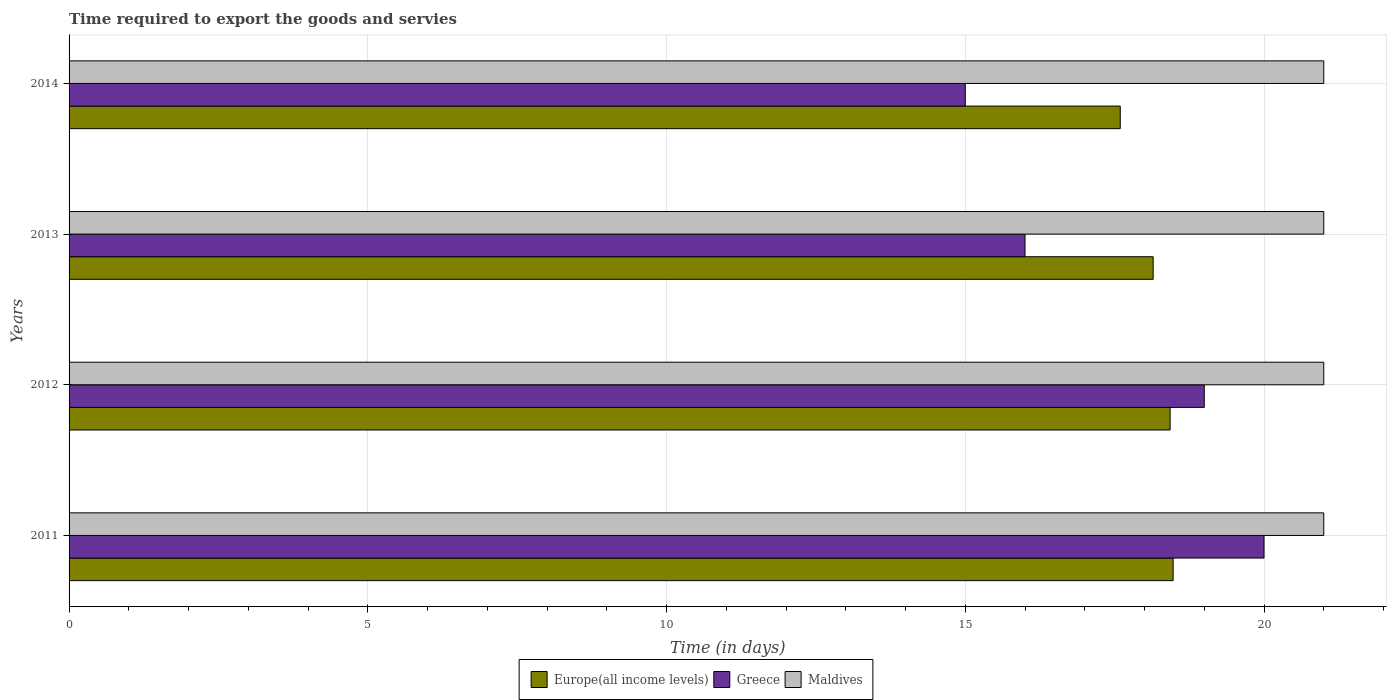How many groups of bars are there?
Give a very brief answer. 4. Are the number of bars per tick equal to the number of legend labels?
Ensure brevity in your answer.  Yes. How many bars are there on the 4th tick from the top?
Ensure brevity in your answer.  3. How many bars are there on the 1st tick from the bottom?
Offer a very short reply. 3. What is the number of days required to export the goods and services in Maldives in 2014?
Keep it short and to the point. 21. Across all years, what is the maximum number of days required to export the goods and services in Greece?
Provide a succinct answer. 20. Across all years, what is the minimum number of days required to export the goods and services in Greece?
Offer a very short reply. 15. In which year was the number of days required to export the goods and services in Europe(all income levels) maximum?
Your answer should be very brief. 2011. What is the total number of days required to export the goods and services in Europe(all income levels) in the graph?
Provide a succinct answer. 72.65. What is the difference between the number of days required to export the goods and services in Greece in 2011 and that in 2012?
Give a very brief answer. 1. What is the difference between the number of days required to export the goods and services in Greece in 2014 and the number of days required to export the goods and services in Europe(all income levels) in 2012?
Offer a very short reply. -3.43. What is the average number of days required to export the goods and services in Maldives per year?
Your answer should be very brief. 21. In the year 2012, what is the difference between the number of days required to export the goods and services in Greece and number of days required to export the goods and services in Europe(all income levels)?
Keep it short and to the point. 0.57. In how many years, is the number of days required to export the goods and services in Europe(all income levels) greater than 10 days?
Make the answer very short. 4. What is the ratio of the number of days required to export the goods and services in Europe(all income levels) in 2012 to that in 2014?
Ensure brevity in your answer.  1.05. Is the difference between the number of days required to export the goods and services in Greece in 2011 and 2013 greater than the difference between the number of days required to export the goods and services in Europe(all income levels) in 2011 and 2013?
Offer a very short reply. Yes. What is the difference between the highest and the second highest number of days required to export the goods and services in Europe(all income levels)?
Provide a short and direct response. 0.05. In how many years, is the number of days required to export the goods and services in Maldives greater than the average number of days required to export the goods and services in Maldives taken over all years?
Your response must be concise. 0. Is the sum of the number of days required to export the goods and services in Europe(all income levels) in 2012 and 2014 greater than the maximum number of days required to export the goods and services in Maldives across all years?
Keep it short and to the point. Yes. What does the 3rd bar from the top in 2014 represents?
Offer a very short reply. Europe(all income levels). What does the 3rd bar from the bottom in 2013 represents?
Your answer should be very brief. Maldives. Is it the case that in every year, the sum of the number of days required to export the goods and services in Greece and number of days required to export the goods and services in Europe(all income levels) is greater than the number of days required to export the goods and services in Maldives?
Provide a succinct answer. Yes. How many bars are there?
Offer a very short reply. 12. Are all the bars in the graph horizontal?
Your answer should be very brief. Yes. How many years are there in the graph?
Ensure brevity in your answer.  4. Are the values on the major ticks of X-axis written in scientific E-notation?
Ensure brevity in your answer.  No. Where does the legend appear in the graph?
Make the answer very short. Bottom center. How many legend labels are there?
Your answer should be very brief. 3. How are the legend labels stacked?
Ensure brevity in your answer.  Horizontal. What is the title of the graph?
Make the answer very short. Time required to export the goods and servies. Does "Lao PDR" appear as one of the legend labels in the graph?
Offer a very short reply. No. What is the label or title of the X-axis?
Your response must be concise. Time (in days). What is the Time (in days) in Europe(all income levels) in 2011?
Offer a very short reply. 18.48. What is the Time (in days) of Greece in 2011?
Your answer should be very brief. 20. What is the Time (in days) of Europe(all income levels) in 2012?
Your answer should be compact. 18.43. What is the Time (in days) in Europe(all income levels) in 2013?
Keep it short and to the point. 18.14. What is the Time (in days) in Greece in 2013?
Offer a very short reply. 16. What is the Time (in days) of Maldives in 2013?
Ensure brevity in your answer.  21. What is the Time (in days) in Europe(all income levels) in 2014?
Give a very brief answer. 17.59. What is the Time (in days) of Greece in 2014?
Your response must be concise. 15. What is the Time (in days) of Maldives in 2014?
Make the answer very short. 21. Across all years, what is the maximum Time (in days) of Europe(all income levels)?
Offer a very short reply. 18.48. Across all years, what is the maximum Time (in days) in Greece?
Offer a very short reply. 20. Across all years, what is the maximum Time (in days) in Maldives?
Provide a succinct answer. 21. Across all years, what is the minimum Time (in days) in Europe(all income levels)?
Keep it short and to the point. 17.59. Across all years, what is the minimum Time (in days) of Maldives?
Your response must be concise. 21. What is the total Time (in days) in Europe(all income levels) in the graph?
Keep it short and to the point. 72.65. What is the total Time (in days) of Greece in the graph?
Give a very brief answer. 70. What is the difference between the Time (in days) in Europe(all income levels) in 2011 and that in 2012?
Give a very brief answer. 0.05. What is the difference between the Time (in days) of Europe(all income levels) in 2011 and that in 2013?
Your answer should be very brief. 0.33. What is the difference between the Time (in days) of Greece in 2011 and that in 2013?
Your answer should be compact. 4. What is the difference between the Time (in days) in Europe(all income levels) in 2011 and that in 2014?
Offer a terse response. 0.89. What is the difference between the Time (in days) in Greece in 2011 and that in 2014?
Your response must be concise. 5. What is the difference between the Time (in days) of Maldives in 2011 and that in 2014?
Your answer should be compact. 0. What is the difference between the Time (in days) in Europe(all income levels) in 2012 and that in 2013?
Provide a short and direct response. 0.28. What is the difference between the Time (in days) in Europe(all income levels) in 2012 and that in 2014?
Your answer should be compact. 0.83. What is the difference between the Time (in days) of Maldives in 2012 and that in 2014?
Make the answer very short. 0. What is the difference between the Time (in days) of Europe(all income levels) in 2013 and that in 2014?
Your answer should be compact. 0.55. What is the difference between the Time (in days) of Greece in 2013 and that in 2014?
Ensure brevity in your answer.  1. What is the difference between the Time (in days) of Maldives in 2013 and that in 2014?
Provide a short and direct response. 0. What is the difference between the Time (in days) in Europe(all income levels) in 2011 and the Time (in days) in Greece in 2012?
Your response must be concise. -0.52. What is the difference between the Time (in days) of Europe(all income levels) in 2011 and the Time (in days) of Maldives in 2012?
Provide a short and direct response. -2.52. What is the difference between the Time (in days) of Greece in 2011 and the Time (in days) of Maldives in 2012?
Make the answer very short. -1. What is the difference between the Time (in days) in Europe(all income levels) in 2011 and the Time (in days) in Greece in 2013?
Your answer should be compact. 2.48. What is the difference between the Time (in days) of Europe(all income levels) in 2011 and the Time (in days) of Maldives in 2013?
Offer a terse response. -2.52. What is the difference between the Time (in days) of Europe(all income levels) in 2011 and the Time (in days) of Greece in 2014?
Provide a succinct answer. 3.48. What is the difference between the Time (in days) in Europe(all income levels) in 2011 and the Time (in days) in Maldives in 2014?
Make the answer very short. -2.52. What is the difference between the Time (in days) of Europe(all income levels) in 2012 and the Time (in days) of Greece in 2013?
Your response must be concise. 2.43. What is the difference between the Time (in days) in Europe(all income levels) in 2012 and the Time (in days) in Maldives in 2013?
Your answer should be compact. -2.57. What is the difference between the Time (in days) in Greece in 2012 and the Time (in days) in Maldives in 2013?
Make the answer very short. -2. What is the difference between the Time (in days) in Europe(all income levels) in 2012 and the Time (in days) in Greece in 2014?
Make the answer very short. 3.43. What is the difference between the Time (in days) of Europe(all income levels) in 2012 and the Time (in days) of Maldives in 2014?
Give a very brief answer. -2.57. What is the difference between the Time (in days) of Greece in 2012 and the Time (in days) of Maldives in 2014?
Make the answer very short. -2. What is the difference between the Time (in days) of Europe(all income levels) in 2013 and the Time (in days) of Greece in 2014?
Your answer should be compact. 3.14. What is the difference between the Time (in days) in Europe(all income levels) in 2013 and the Time (in days) in Maldives in 2014?
Ensure brevity in your answer.  -2.86. What is the difference between the Time (in days) in Greece in 2013 and the Time (in days) in Maldives in 2014?
Offer a terse response. -5. What is the average Time (in days) in Europe(all income levels) per year?
Provide a succinct answer. 18.16. What is the average Time (in days) in Greece per year?
Offer a terse response. 17.5. In the year 2011, what is the difference between the Time (in days) of Europe(all income levels) and Time (in days) of Greece?
Provide a short and direct response. -1.52. In the year 2011, what is the difference between the Time (in days) of Europe(all income levels) and Time (in days) of Maldives?
Give a very brief answer. -2.52. In the year 2011, what is the difference between the Time (in days) of Greece and Time (in days) of Maldives?
Your response must be concise. -1. In the year 2012, what is the difference between the Time (in days) of Europe(all income levels) and Time (in days) of Greece?
Offer a very short reply. -0.57. In the year 2012, what is the difference between the Time (in days) of Europe(all income levels) and Time (in days) of Maldives?
Keep it short and to the point. -2.57. In the year 2013, what is the difference between the Time (in days) in Europe(all income levels) and Time (in days) in Greece?
Your answer should be very brief. 2.14. In the year 2013, what is the difference between the Time (in days) in Europe(all income levels) and Time (in days) in Maldives?
Your response must be concise. -2.86. In the year 2014, what is the difference between the Time (in days) of Europe(all income levels) and Time (in days) of Greece?
Ensure brevity in your answer.  2.59. In the year 2014, what is the difference between the Time (in days) of Europe(all income levels) and Time (in days) of Maldives?
Give a very brief answer. -3.41. In the year 2014, what is the difference between the Time (in days) of Greece and Time (in days) of Maldives?
Your answer should be compact. -6. What is the ratio of the Time (in days) in Europe(all income levels) in 2011 to that in 2012?
Your response must be concise. 1. What is the ratio of the Time (in days) in Greece in 2011 to that in 2012?
Give a very brief answer. 1.05. What is the ratio of the Time (in days) of Maldives in 2011 to that in 2012?
Keep it short and to the point. 1. What is the ratio of the Time (in days) in Europe(all income levels) in 2011 to that in 2013?
Keep it short and to the point. 1.02. What is the ratio of the Time (in days) in Greece in 2011 to that in 2013?
Give a very brief answer. 1.25. What is the ratio of the Time (in days) of Maldives in 2011 to that in 2013?
Ensure brevity in your answer.  1. What is the ratio of the Time (in days) in Europe(all income levels) in 2011 to that in 2014?
Make the answer very short. 1.05. What is the ratio of the Time (in days) in Greece in 2011 to that in 2014?
Your answer should be very brief. 1.33. What is the ratio of the Time (in days) in Maldives in 2011 to that in 2014?
Offer a terse response. 1. What is the ratio of the Time (in days) of Europe(all income levels) in 2012 to that in 2013?
Provide a short and direct response. 1.02. What is the ratio of the Time (in days) in Greece in 2012 to that in 2013?
Give a very brief answer. 1.19. What is the ratio of the Time (in days) of Maldives in 2012 to that in 2013?
Your response must be concise. 1. What is the ratio of the Time (in days) of Europe(all income levels) in 2012 to that in 2014?
Your answer should be very brief. 1.05. What is the ratio of the Time (in days) in Greece in 2012 to that in 2014?
Offer a terse response. 1.27. What is the ratio of the Time (in days) in Maldives in 2012 to that in 2014?
Give a very brief answer. 1. What is the ratio of the Time (in days) in Europe(all income levels) in 2013 to that in 2014?
Your answer should be very brief. 1.03. What is the ratio of the Time (in days) of Greece in 2013 to that in 2014?
Your answer should be very brief. 1.07. What is the ratio of the Time (in days) of Maldives in 2013 to that in 2014?
Provide a succinct answer. 1. What is the difference between the highest and the second highest Time (in days) in Europe(all income levels)?
Offer a terse response. 0.05. What is the difference between the highest and the lowest Time (in days) of Europe(all income levels)?
Your response must be concise. 0.89. What is the difference between the highest and the lowest Time (in days) of Greece?
Provide a short and direct response. 5. What is the difference between the highest and the lowest Time (in days) of Maldives?
Your answer should be very brief. 0. 